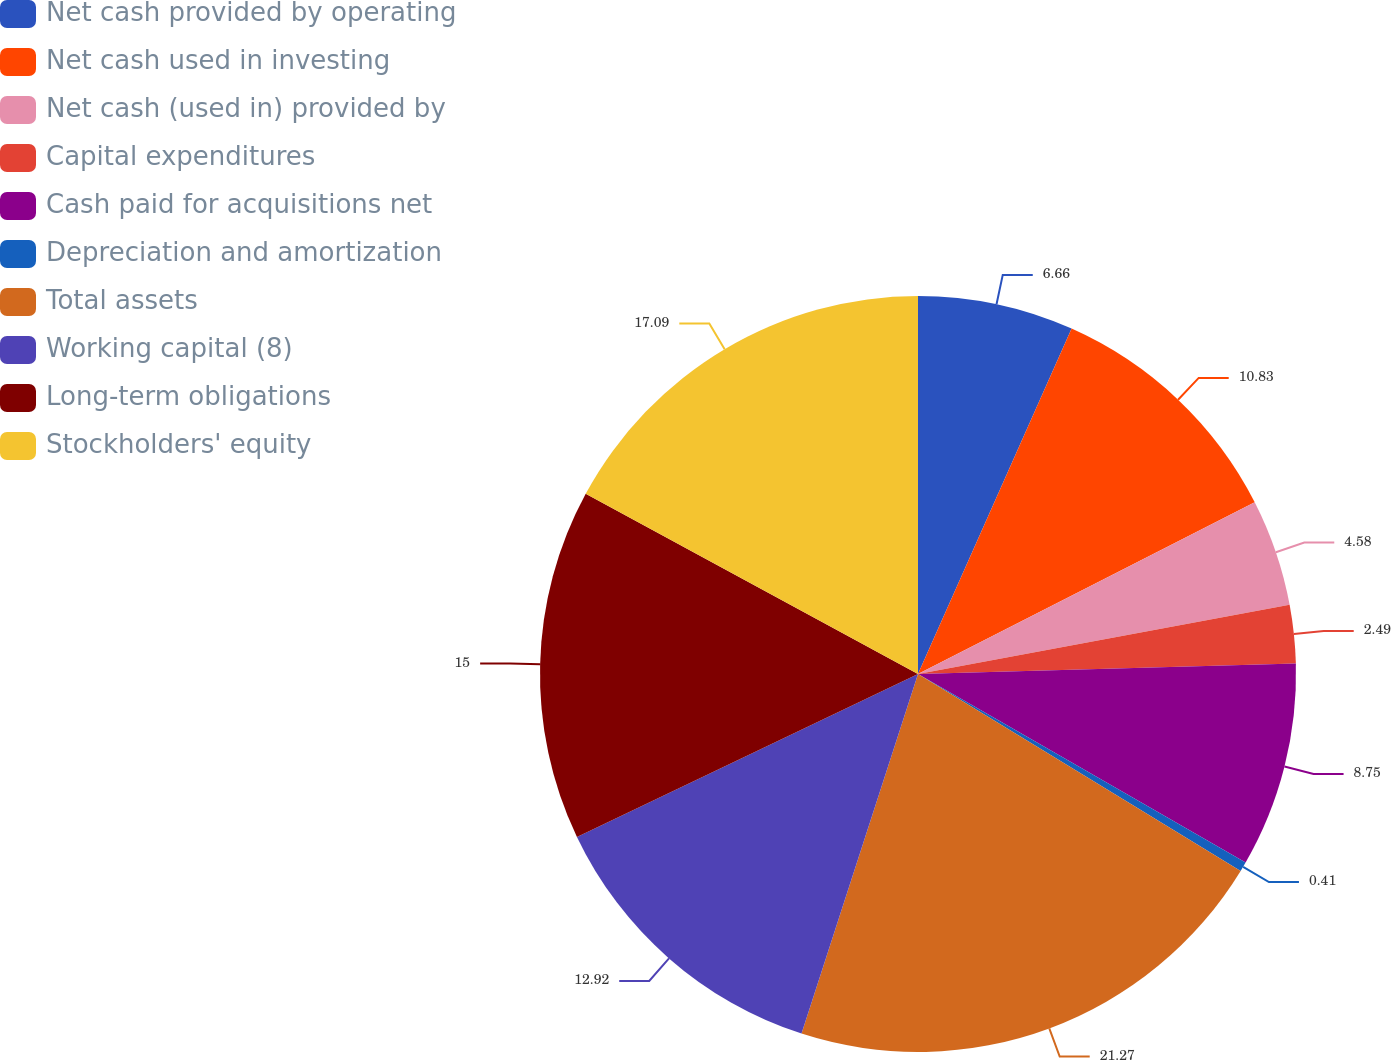Convert chart. <chart><loc_0><loc_0><loc_500><loc_500><pie_chart><fcel>Net cash provided by operating<fcel>Net cash used in investing<fcel>Net cash (used in) provided by<fcel>Capital expenditures<fcel>Cash paid for acquisitions net<fcel>Depreciation and amortization<fcel>Total assets<fcel>Working capital (8)<fcel>Long-term obligations<fcel>Stockholders' equity<nl><fcel>6.66%<fcel>10.83%<fcel>4.58%<fcel>2.49%<fcel>8.75%<fcel>0.41%<fcel>21.26%<fcel>12.92%<fcel>15.0%<fcel>17.09%<nl></chart> 